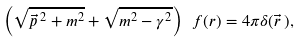Convert formula to latex. <formula><loc_0><loc_0><loc_500><loc_500>\left ( \sqrt { \vec { p } \, ^ { 2 } + m ^ { 2 } } + \sqrt { m ^ { 2 } - \gamma ^ { 2 } } \right ) \ f ( r ) = 4 \pi \delta ( \vec { r } \, ) ,</formula> 